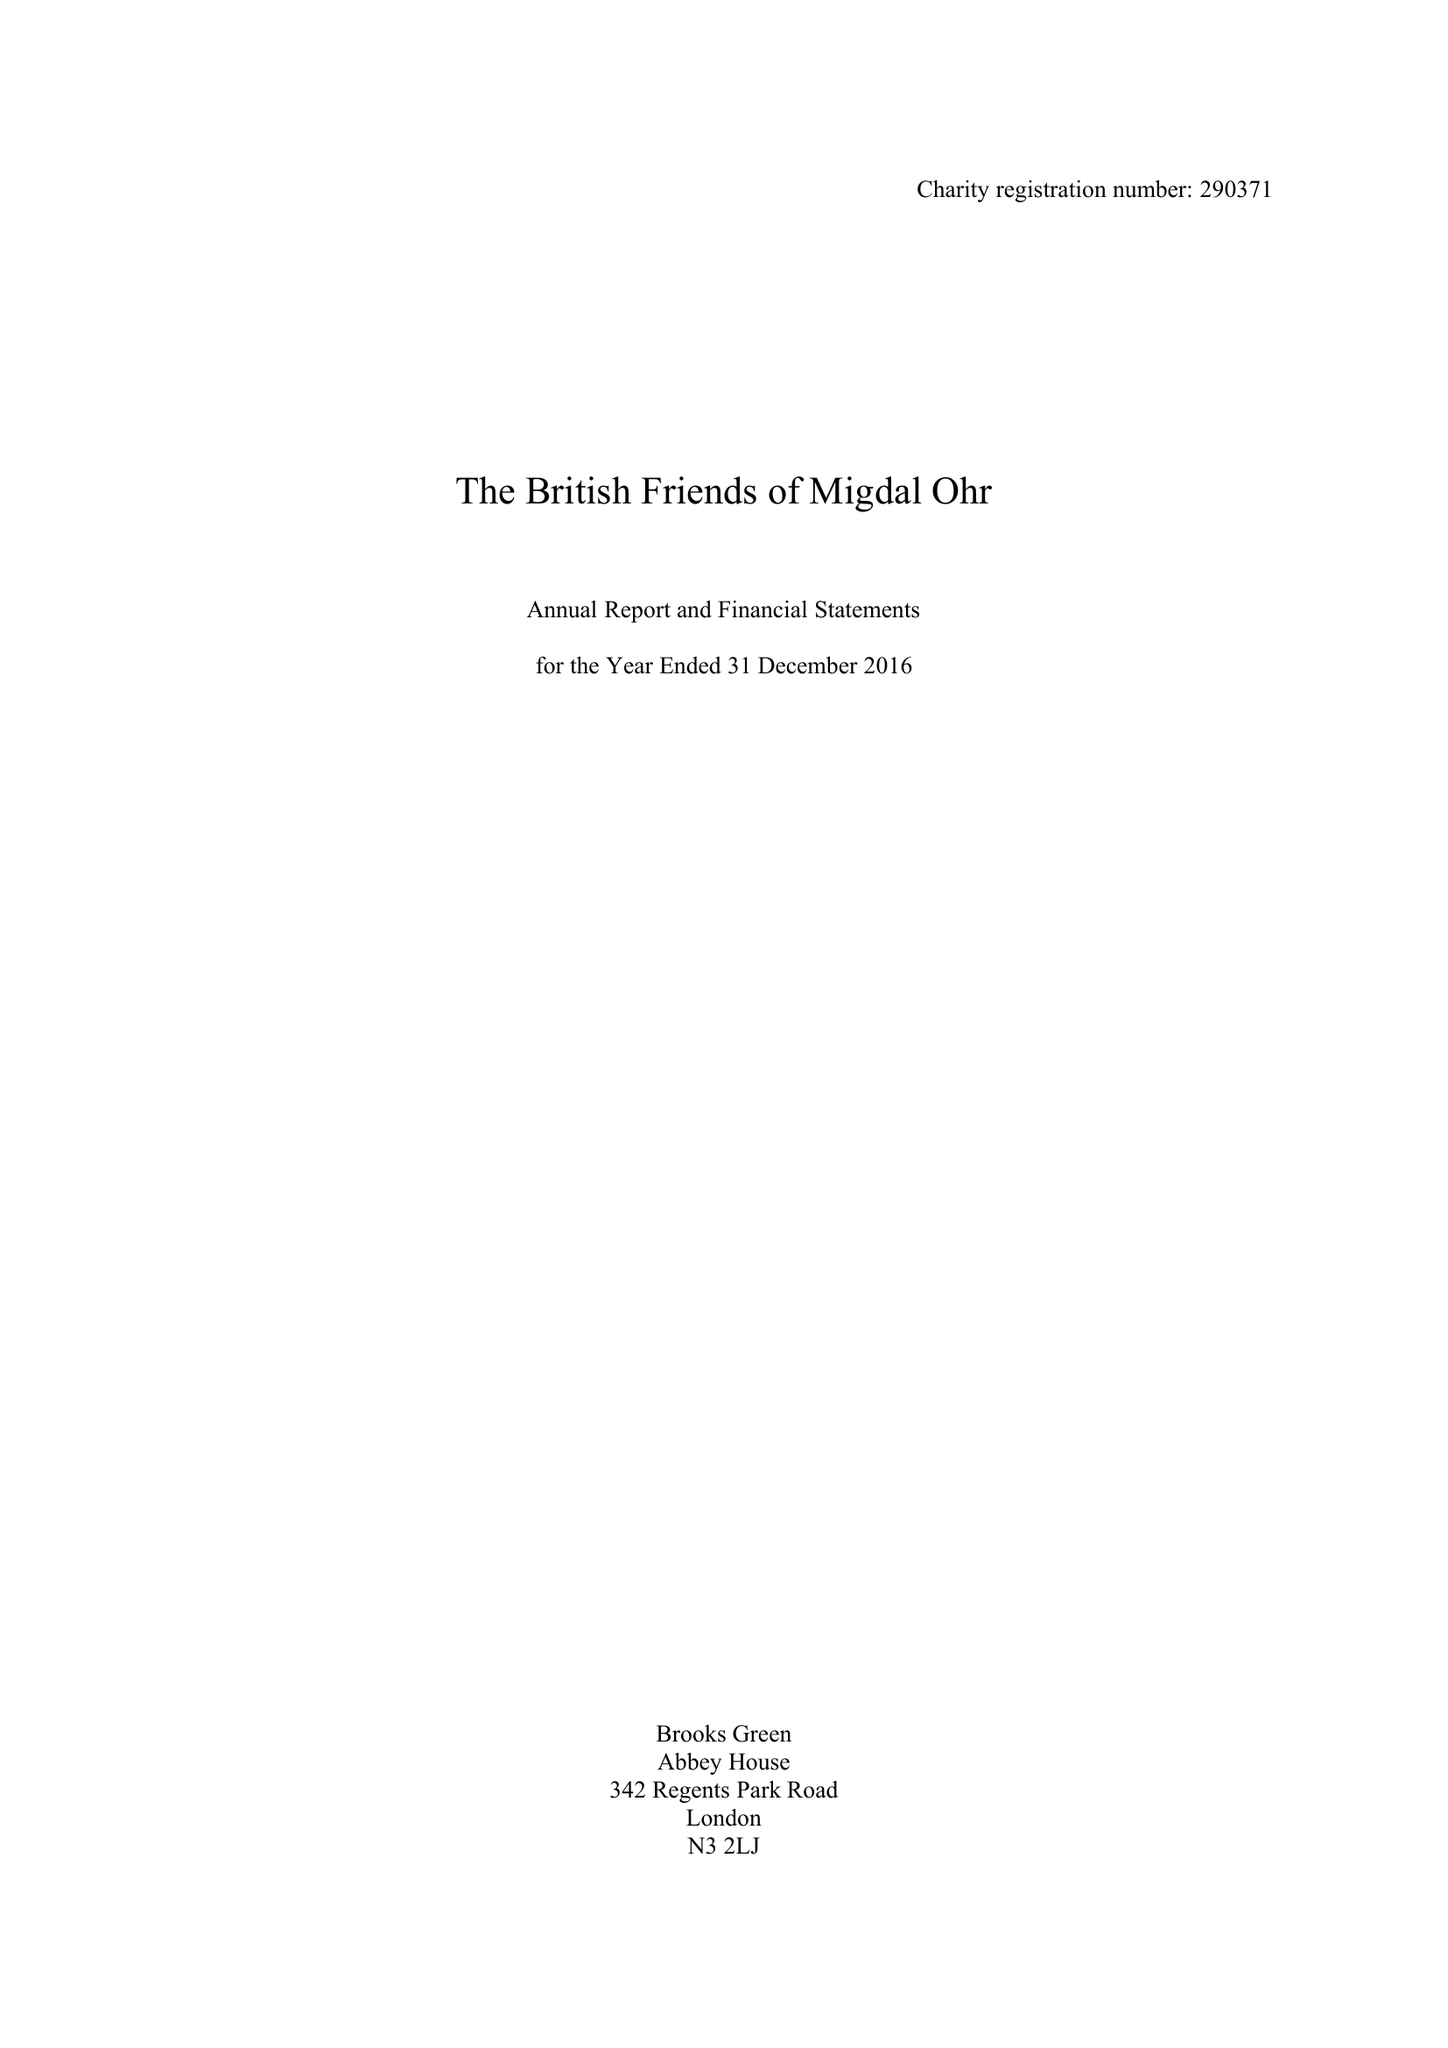What is the value for the address__postcode?
Answer the question using a single word or phrase. W1H 6EG 